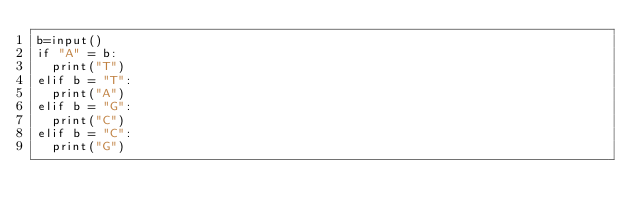<code> <loc_0><loc_0><loc_500><loc_500><_Python_>b=input()
if "A" = b:
  print("T")
elif b = "T":
  print("A")
elif b = "G":
  print("C")
elif b = "C":
  print("G")</code> 